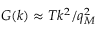Convert formula to latex. <formula><loc_0><loc_0><loc_500><loc_500>G ( k ) \approx T k ^ { 2 } / q _ { M } ^ { 2 }</formula> 